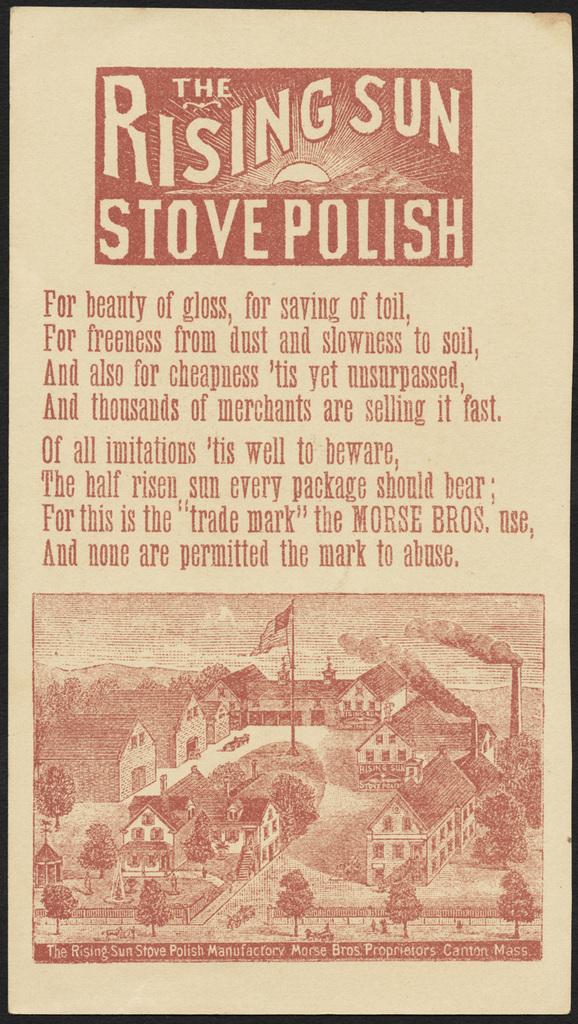What does the first line say?
Provide a short and direct response. For beauty of gloss, for saving of toil,. What is the name?
Provide a short and direct response. The rising sun stove polish. 